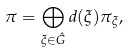<formula> <loc_0><loc_0><loc_500><loc_500>\pi = \bigoplus _ { \xi \in \hat { G } } d ( \xi ) \pi _ { \xi } ,</formula> 